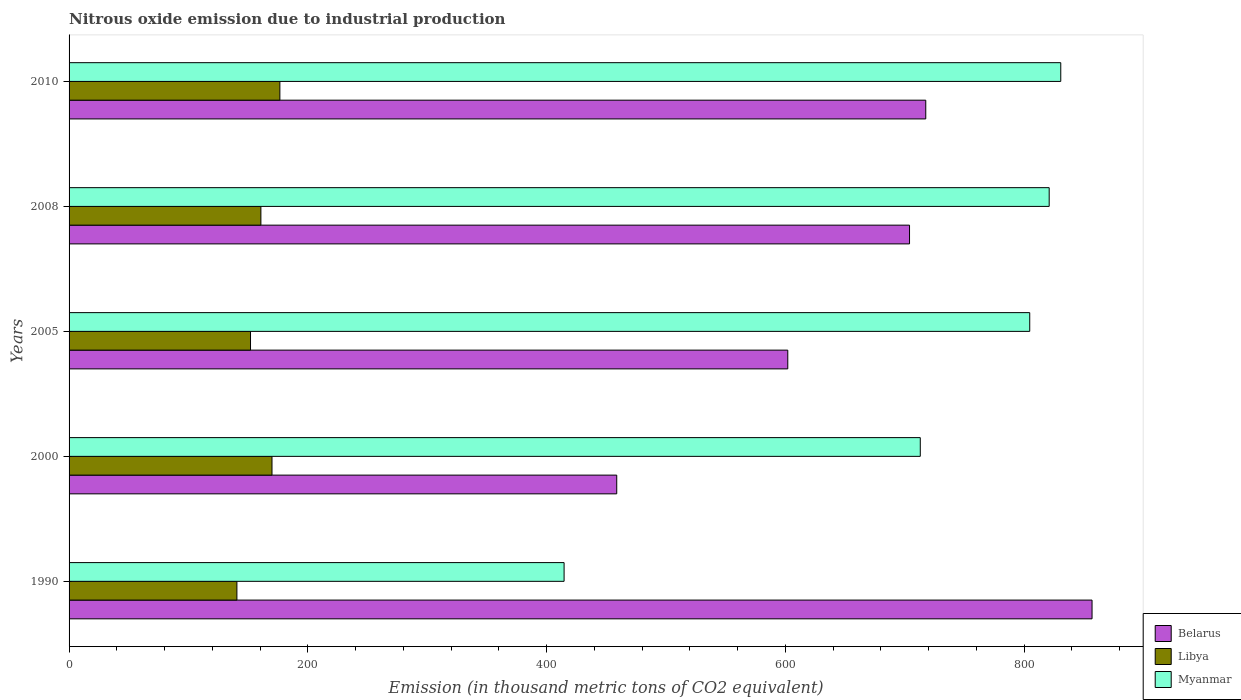How many different coloured bars are there?
Make the answer very short. 3. How many bars are there on the 4th tick from the bottom?
Your answer should be compact. 3. What is the label of the 5th group of bars from the top?
Provide a succinct answer. 1990. In how many cases, is the number of bars for a given year not equal to the number of legend labels?
Give a very brief answer. 0. What is the amount of nitrous oxide emitted in Libya in 2005?
Provide a short and direct response. 152. Across all years, what is the maximum amount of nitrous oxide emitted in Belarus?
Offer a terse response. 857. Across all years, what is the minimum amount of nitrous oxide emitted in Belarus?
Your answer should be very brief. 458.8. What is the total amount of nitrous oxide emitted in Myanmar in the graph?
Offer a very short reply. 3584.5. What is the difference between the amount of nitrous oxide emitted in Belarus in 1990 and that in 2010?
Offer a very short reply. 139.3. What is the difference between the amount of nitrous oxide emitted in Libya in 2010 and the amount of nitrous oxide emitted in Belarus in 2000?
Provide a succinct answer. -282.2. What is the average amount of nitrous oxide emitted in Belarus per year?
Your answer should be very brief. 667.94. In the year 2008, what is the difference between the amount of nitrous oxide emitted in Myanmar and amount of nitrous oxide emitted in Belarus?
Offer a terse response. 117. In how many years, is the amount of nitrous oxide emitted in Libya greater than 640 thousand metric tons?
Make the answer very short. 0. What is the ratio of the amount of nitrous oxide emitted in Libya in 1990 to that in 2008?
Keep it short and to the point. 0.87. What is the difference between the highest and the second highest amount of nitrous oxide emitted in Libya?
Your answer should be compact. 6.6. What is the difference between the highest and the lowest amount of nitrous oxide emitted in Myanmar?
Provide a succinct answer. 416.1. What does the 2nd bar from the top in 1990 represents?
Offer a terse response. Libya. What does the 2nd bar from the bottom in 1990 represents?
Keep it short and to the point. Libya. Are all the bars in the graph horizontal?
Keep it short and to the point. Yes. How many years are there in the graph?
Make the answer very short. 5. Are the values on the major ticks of X-axis written in scientific E-notation?
Give a very brief answer. No. Does the graph contain grids?
Your answer should be very brief. No. What is the title of the graph?
Provide a short and direct response. Nitrous oxide emission due to industrial production. What is the label or title of the X-axis?
Make the answer very short. Emission (in thousand metric tons of CO2 equivalent). What is the label or title of the Y-axis?
Offer a very short reply. Years. What is the Emission (in thousand metric tons of CO2 equivalent) in Belarus in 1990?
Keep it short and to the point. 857. What is the Emission (in thousand metric tons of CO2 equivalent) of Libya in 1990?
Provide a succinct answer. 140.6. What is the Emission (in thousand metric tons of CO2 equivalent) in Myanmar in 1990?
Give a very brief answer. 414.7. What is the Emission (in thousand metric tons of CO2 equivalent) of Belarus in 2000?
Your answer should be compact. 458.8. What is the Emission (in thousand metric tons of CO2 equivalent) of Libya in 2000?
Your answer should be compact. 170. What is the Emission (in thousand metric tons of CO2 equivalent) in Myanmar in 2000?
Give a very brief answer. 713.1. What is the Emission (in thousand metric tons of CO2 equivalent) in Belarus in 2005?
Give a very brief answer. 602.1. What is the Emission (in thousand metric tons of CO2 equivalent) in Libya in 2005?
Your answer should be compact. 152. What is the Emission (in thousand metric tons of CO2 equivalent) in Myanmar in 2005?
Give a very brief answer. 804.8. What is the Emission (in thousand metric tons of CO2 equivalent) in Belarus in 2008?
Keep it short and to the point. 704.1. What is the Emission (in thousand metric tons of CO2 equivalent) of Libya in 2008?
Give a very brief answer. 160.7. What is the Emission (in thousand metric tons of CO2 equivalent) of Myanmar in 2008?
Provide a succinct answer. 821.1. What is the Emission (in thousand metric tons of CO2 equivalent) of Belarus in 2010?
Ensure brevity in your answer.  717.7. What is the Emission (in thousand metric tons of CO2 equivalent) of Libya in 2010?
Give a very brief answer. 176.6. What is the Emission (in thousand metric tons of CO2 equivalent) of Myanmar in 2010?
Provide a short and direct response. 830.8. Across all years, what is the maximum Emission (in thousand metric tons of CO2 equivalent) of Belarus?
Provide a short and direct response. 857. Across all years, what is the maximum Emission (in thousand metric tons of CO2 equivalent) of Libya?
Keep it short and to the point. 176.6. Across all years, what is the maximum Emission (in thousand metric tons of CO2 equivalent) in Myanmar?
Give a very brief answer. 830.8. Across all years, what is the minimum Emission (in thousand metric tons of CO2 equivalent) in Belarus?
Make the answer very short. 458.8. Across all years, what is the minimum Emission (in thousand metric tons of CO2 equivalent) in Libya?
Make the answer very short. 140.6. Across all years, what is the minimum Emission (in thousand metric tons of CO2 equivalent) in Myanmar?
Your answer should be compact. 414.7. What is the total Emission (in thousand metric tons of CO2 equivalent) of Belarus in the graph?
Provide a succinct answer. 3339.7. What is the total Emission (in thousand metric tons of CO2 equivalent) in Libya in the graph?
Give a very brief answer. 799.9. What is the total Emission (in thousand metric tons of CO2 equivalent) in Myanmar in the graph?
Your response must be concise. 3584.5. What is the difference between the Emission (in thousand metric tons of CO2 equivalent) of Belarus in 1990 and that in 2000?
Provide a succinct answer. 398.2. What is the difference between the Emission (in thousand metric tons of CO2 equivalent) of Libya in 1990 and that in 2000?
Your answer should be compact. -29.4. What is the difference between the Emission (in thousand metric tons of CO2 equivalent) of Myanmar in 1990 and that in 2000?
Your response must be concise. -298.4. What is the difference between the Emission (in thousand metric tons of CO2 equivalent) in Belarus in 1990 and that in 2005?
Give a very brief answer. 254.9. What is the difference between the Emission (in thousand metric tons of CO2 equivalent) of Myanmar in 1990 and that in 2005?
Keep it short and to the point. -390.1. What is the difference between the Emission (in thousand metric tons of CO2 equivalent) of Belarus in 1990 and that in 2008?
Your answer should be compact. 152.9. What is the difference between the Emission (in thousand metric tons of CO2 equivalent) in Libya in 1990 and that in 2008?
Keep it short and to the point. -20.1. What is the difference between the Emission (in thousand metric tons of CO2 equivalent) in Myanmar in 1990 and that in 2008?
Offer a very short reply. -406.4. What is the difference between the Emission (in thousand metric tons of CO2 equivalent) of Belarus in 1990 and that in 2010?
Make the answer very short. 139.3. What is the difference between the Emission (in thousand metric tons of CO2 equivalent) in Libya in 1990 and that in 2010?
Offer a terse response. -36. What is the difference between the Emission (in thousand metric tons of CO2 equivalent) in Myanmar in 1990 and that in 2010?
Offer a very short reply. -416.1. What is the difference between the Emission (in thousand metric tons of CO2 equivalent) of Belarus in 2000 and that in 2005?
Ensure brevity in your answer.  -143.3. What is the difference between the Emission (in thousand metric tons of CO2 equivalent) in Myanmar in 2000 and that in 2005?
Give a very brief answer. -91.7. What is the difference between the Emission (in thousand metric tons of CO2 equivalent) of Belarus in 2000 and that in 2008?
Offer a very short reply. -245.3. What is the difference between the Emission (in thousand metric tons of CO2 equivalent) of Libya in 2000 and that in 2008?
Make the answer very short. 9.3. What is the difference between the Emission (in thousand metric tons of CO2 equivalent) in Myanmar in 2000 and that in 2008?
Provide a short and direct response. -108. What is the difference between the Emission (in thousand metric tons of CO2 equivalent) in Belarus in 2000 and that in 2010?
Provide a short and direct response. -258.9. What is the difference between the Emission (in thousand metric tons of CO2 equivalent) of Libya in 2000 and that in 2010?
Provide a succinct answer. -6.6. What is the difference between the Emission (in thousand metric tons of CO2 equivalent) of Myanmar in 2000 and that in 2010?
Offer a terse response. -117.7. What is the difference between the Emission (in thousand metric tons of CO2 equivalent) in Belarus in 2005 and that in 2008?
Keep it short and to the point. -102. What is the difference between the Emission (in thousand metric tons of CO2 equivalent) in Libya in 2005 and that in 2008?
Keep it short and to the point. -8.7. What is the difference between the Emission (in thousand metric tons of CO2 equivalent) of Myanmar in 2005 and that in 2008?
Your answer should be compact. -16.3. What is the difference between the Emission (in thousand metric tons of CO2 equivalent) of Belarus in 2005 and that in 2010?
Your answer should be very brief. -115.6. What is the difference between the Emission (in thousand metric tons of CO2 equivalent) in Libya in 2005 and that in 2010?
Your response must be concise. -24.6. What is the difference between the Emission (in thousand metric tons of CO2 equivalent) in Belarus in 2008 and that in 2010?
Keep it short and to the point. -13.6. What is the difference between the Emission (in thousand metric tons of CO2 equivalent) of Libya in 2008 and that in 2010?
Ensure brevity in your answer.  -15.9. What is the difference between the Emission (in thousand metric tons of CO2 equivalent) of Myanmar in 2008 and that in 2010?
Your answer should be compact. -9.7. What is the difference between the Emission (in thousand metric tons of CO2 equivalent) in Belarus in 1990 and the Emission (in thousand metric tons of CO2 equivalent) in Libya in 2000?
Your answer should be compact. 687. What is the difference between the Emission (in thousand metric tons of CO2 equivalent) of Belarus in 1990 and the Emission (in thousand metric tons of CO2 equivalent) of Myanmar in 2000?
Ensure brevity in your answer.  143.9. What is the difference between the Emission (in thousand metric tons of CO2 equivalent) of Libya in 1990 and the Emission (in thousand metric tons of CO2 equivalent) of Myanmar in 2000?
Provide a succinct answer. -572.5. What is the difference between the Emission (in thousand metric tons of CO2 equivalent) of Belarus in 1990 and the Emission (in thousand metric tons of CO2 equivalent) of Libya in 2005?
Offer a very short reply. 705. What is the difference between the Emission (in thousand metric tons of CO2 equivalent) of Belarus in 1990 and the Emission (in thousand metric tons of CO2 equivalent) of Myanmar in 2005?
Offer a very short reply. 52.2. What is the difference between the Emission (in thousand metric tons of CO2 equivalent) in Libya in 1990 and the Emission (in thousand metric tons of CO2 equivalent) in Myanmar in 2005?
Provide a short and direct response. -664.2. What is the difference between the Emission (in thousand metric tons of CO2 equivalent) in Belarus in 1990 and the Emission (in thousand metric tons of CO2 equivalent) in Libya in 2008?
Offer a terse response. 696.3. What is the difference between the Emission (in thousand metric tons of CO2 equivalent) of Belarus in 1990 and the Emission (in thousand metric tons of CO2 equivalent) of Myanmar in 2008?
Ensure brevity in your answer.  35.9. What is the difference between the Emission (in thousand metric tons of CO2 equivalent) in Libya in 1990 and the Emission (in thousand metric tons of CO2 equivalent) in Myanmar in 2008?
Your answer should be compact. -680.5. What is the difference between the Emission (in thousand metric tons of CO2 equivalent) of Belarus in 1990 and the Emission (in thousand metric tons of CO2 equivalent) of Libya in 2010?
Give a very brief answer. 680.4. What is the difference between the Emission (in thousand metric tons of CO2 equivalent) in Belarus in 1990 and the Emission (in thousand metric tons of CO2 equivalent) in Myanmar in 2010?
Your answer should be very brief. 26.2. What is the difference between the Emission (in thousand metric tons of CO2 equivalent) in Libya in 1990 and the Emission (in thousand metric tons of CO2 equivalent) in Myanmar in 2010?
Your answer should be very brief. -690.2. What is the difference between the Emission (in thousand metric tons of CO2 equivalent) of Belarus in 2000 and the Emission (in thousand metric tons of CO2 equivalent) of Libya in 2005?
Ensure brevity in your answer.  306.8. What is the difference between the Emission (in thousand metric tons of CO2 equivalent) of Belarus in 2000 and the Emission (in thousand metric tons of CO2 equivalent) of Myanmar in 2005?
Keep it short and to the point. -346. What is the difference between the Emission (in thousand metric tons of CO2 equivalent) of Libya in 2000 and the Emission (in thousand metric tons of CO2 equivalent) of Myanmar in 2005?
Offer a very short reply. -634.8. What is the difference between the Emission (in thousand metric tons of CO2 equivalent) in Belarus in 2000 and the Emission (in thousand metric tons of CO2 equivalent) in Libya in 2008?
Offer a very short reply. 298.1. What is the difference between the Emission (in thousand metric tons of CO2 equivalent) in Belarus in 2000 and the Emission (in thousand metric tons of CO2 equivalent) in Myanmar in 2008?
Keep it short and to the point. -362.3. What is the difference between the Emission (in thousand metric tons of CO2 equivalent) in Libya in 2000 and the Emission (in thousand metric tons of CO2 equivalent) in Myanmar in 2008?
Provide a succinct answer. -651.1. What is the difference between the Emission (in thousand metric tons of CO2 equivalent) of Belarus in 2000 and the Emission (in thousand metric tons of CO2 equivalent) of Libya in 2010?
Your answer should be very brief. 282.2. What is the difference between the Emission (in thousand metric tons of CO2 equivalent) in Belarus in 2000 and the Emission (in thousand metric tons of CO2 equivalent) in Myanmar in 2010?
Your answer should be very brief. -372. What is the difference between the Emission (in thousand metric tons of CO2 equivalent) in Libya in 2000 and the Emission (in thousand metric tons of CO2 equivalent) in Myanmar in 2010?
Keep it short and to the point. -660.8. What is the difference between the Emission (in thousand metric tons of CO2 equivalent) in Belarus in 2005 and the Emission (in thousand metric tons of CO2 equivalent) in Libya in 2008?
Your response must be concise. 441.4. What is the difference between the Emission (in thousand metric tons of CO2 equivalent) in Belarus in 2005 and the Emission (in thousand metric tons of CO2 equivalent) in Myanmar in 2008?
Provide a short and direct response. -219. What is the difference between the Emission (in thousand metric tons of CO2 equivalent) of Libya in 2005 and the Emission (in thousand metric tons of CO2 equivalent) of Myanmar in 2008?
Your response must be concise. -669.1. What is the difference between the Emission (in thousand metric tons of CO2 equivalent) of Belarus in 2005 and the Emission (in thousand metric tons of CO2 equivalent) of Libya in 2010?
Make the answer very short. 425.5. What is the difference between the Emission (in thousand metric tons of CO2 equivalent) of Belarus in 2005 and the Emission (in thousand metric tons of CO2 equivalent) of Myanmar in 2010?
Your answer should be very brief. -228.7. What is the difference between the Emission (in thousand metric tons of CO2 equivalent) in Libya in 2005 and the Emission (in thousand metric tons of CO2 equivalent) in Myanmar in 2010?
Ensure brevity in your answer.  -678.8. What is the difference between the Emission (in thousand metric tons of CO2 equivalent) in Belarus in 2008 and the Emission (in thousand metric tons of CO2 equivalent) in Libya in 2010?
Give a very brief answer. 527.5. What is the difference between the Emission (in thousand metric tons of CO2 equivalent) in Belarus in 2008 and the Emission (in thousand metric tons of CO2 equivalent) in Myanmar in 2010?
Make the answer very short. -126.7. What is the difference between the Emission (in thousand metric tons of CO2 equivalent) of Libya in 2008 and the Emission (in thousand metric tons of CO2 equivalent) of Myanmar in 2010?
Offer a terse response. -670.1. What is the average Emission (in thousand metric tons of CO2 equivalent) of Belarus per year?
Provide a short and direct response. 667.94. What is the average Emission (in thousand metric tons of CO2 equivalent) in Libya per year?
Keep it short and to the point. 159.98. What is the average Emission (in thousand metric tons of CO2 equivalent) in Myanmar per year?
Give a very brief answer. 716.9. In the year 1990, what is the difference between the Emission (in thousand metric tons of CO2 equivalent) in Belarus and Emission (in thousand metric tons of CO2 equivalent) in Libya?
Offer a terse response. 716.4. In the year 1990, what is the difference between the Emission (in thousand metric tons of CO2 equivalent) of Belarus and Emission (in thousand metric tons of CO2 equivalent) of Myanmar?
Ensure brevity in your answer.  442.3. In the year 1990, what is the difference between the Emission (in thousand metric tons of CO2 equivalent) in Libya and Emission (in thousand metric tons of CO2 equivalent) in Myanmar?
Your answer should be very brief. -274.1. In the year 2000, what is the difference between the Emission (in thousand metric tons of CO2 equivalent) of Belarus and Emission (in thousand metric tons of CO2 equivalent) of Libya?
Offer a terse response. 288.8. In the year 2000, what is the difference between the Emission (in thousand metric tons of CO2 equivalent) of Belarus and Emission (in thousand metric tons of CO2 equivalent) of Myanmar?
Offer a very short reply. -254.3. In the year 2000, what is the difference between the Emission (in thousand metric tons of CO2 equivalent) of Libya and Emission (in thousand metric tons of CO2 equivalent) of Myanmar?
Your answer should be compact. -543.1. In the year 2005, what is the difference between the Emission (in thousand metric tons of CO2 equivalent) in Belarus and Emission (in thousand metric tons of CO2 equivalent) in Libya?
Ensure brevity in your answer.  450.1. In the year 2005, what is the difference between the Emission (in thousand metric tons of CO2 equivalent) of Belarus and Emission (in thousand metric tons of CO2 equivalent) of Myanmar?
Keep it short and to the point. -202.7. In the year 2005, what is the difference between the Emission (in thousand metric tons of CO2 equivalent) in Libya and Emission (in thousand metric tons of CO2 equivalent) in Myanmar?
Offer a terse response. -652.8. In the year 2008, what is the difference between the Emission (in thousand metric tons of CO2 equivalent) of Belarus and Emission (in thousand metric tons of CO2 equivalent) of Libya?
Ensure brevity in your answer.  543.4. In the year 2008, what is the difference between the Emission (in thousand metric tons of CO2 equivalent) of Belarus and Emission (in thousand metric tons of CO2 equivalent) of Myanmar?
Provide a succinct answer. -117. In the year 2008, what is the difference between the Emission (in thousand metric tons of CO2 equivalent) of Libya and Emission (in thousand metric tons of CO2 equivalent) of Myanmar?
Offer a terse response. -660.4. In the year 2010, what is the difference between the Emission (in thousand metric tons of CO2 equivalent) in Belarus and Emission (in thousand metric tons of CO2 equivalent) in Libya?
Give a very brief answer. 541.1. In the year 2010, what is the difference between the Emission (in thousand metric tons of CO2 equivalent) in Belarus and Emission (in thousand metric tons of CO2 equivalent) in Myanmar?
Provide a succinct answer. -113.1. In the year 2010, what is the difference between the Emission (in thousand metric tons of CO2 equivalent) in Libya and Emission (in thousand metric tons of CO2 equivalent) in Myanmar?
Your answer should be very brief. -654.2. What is the ratio of the Emission (in thousand metric tons of CO2 equivalent) of Belarus in 1990 to that in 2000?
Give a very brief answer. 1.87. What is the ratio of the Emission (in thousand metric tons of CO2 equivalent) in Libya in 1990 to that in 2000?
Your response must be concise. 0.83. What is the ratio of the Emission (in thousand metric tons of CO2 equivalent) of Myanmar in 1990 to that in 2000?
Give a very brief answer. 0.58. What is the ratio of the Emission (in thousand metric tons of CO2 equivalent) in Belarus in 1990 to that in 2005?
Ensure brevity in your answer.  1.42. What is the ratio of the Emission (in thousand metric tons of CO2 equivalent) in Libya in 1990 to that in 2005?
Keep it short and to the point. 0.93. What is the ratio of the Emission (in thousand metric tons of CO2 equivalent) in Myanmar in 1990 to that in 2005?
Your answer should be compact. 0.52. What is the ratio of the Emission (in thousand metric tons of CO2 equivalent) in Belarus in 1990 to that in 2008?
Ensure brevity in your answer.  1.22. What is the ratio of the Emission (in thousand metric tons of CO2 equivalent) of Libya in 1990 to that in 2008?
Your response must be concise. 0.87. What is the ratio of the Emission (in thousand metric tons of CO2 equivalent) in Myanmar in 1990 to that in 2008?
Your answer should be very brief. 0.51. What is the ratio of the Emission (in thousand metric tons of CO2 equivalent) in Belarus in 1990 to that in 2010?
Make the answer very short. 1.19. What is the ratio of the Emission (in thousand metric tons of CO2 equivalent) of Libya in 1990 to that in 2010?
Your answer should be compact. 0.8. What is the ratio of the Emission (in thousand metric tons of CO2 equivalent) of Myanmar in 1990 to that in 2010?
Your answer should be compact. 0.5. What is the ratio of the Emission (in thousand metric tons of CO2 equivalent) of Belarus in 2000 to that in 2005?
Give a very brief answer. 0.76. What is the ratio of the Emission (in thousand metric tons of CO2 equivalent) of Libya in 2000 to that in 2005?
Provide a succinct answer. 1.12. What is the ratio of the Emission (in thousand metric tons of CO2 equivalent) of Myanmar in 2000 to that in 2005?
Offer a very short reply. 0.89. What is the ratio of the Emission (in thousand metric tons of CO2 equivalent) of Belarus in 2000 to that in 2008?
Your answer should be compact. 0.65. What is the ratio of the Emission (in thousand metric tons of CO2 equivalent) in Libya in 2000 to that in 2008?
Provide a succinct answer. 1.06. What is the ratio of the Emission (in thousand metric tons of CO2 equivalent) of Myanmar in 2000 to that in 2008?
Keep it short and to the point. 0.87. What is the ratio of the Emission (in thousand metric tons of CO2 equivalent) of Belarus in 2000 to that in 2010?
Keep it short and to the point. 0.64. What is the ratio of the Emission (in thousand metric tons of CO2 equivalent) in Libya in 2000 to that in 2010?
Provide a succinct answer. 0.96. What is the ratio of the Emission (in thousand metric tons of CO2 equivalent) in Myanmar in 2000 to that in 2010?
Your response must be concise. 0.86. What is the ratio of the Emission (in thousand metric tons of CO2 equivalent) of Belarus in 2005 to that in 2008?
Ensure brevity in your answer.  0.86. What is the ratio of the Emission (in thousand metric tons of CO2 equivalent) of Libya in 2005 to that in 2008?
Offer a very short reply. 0.95. What is the ratio of the Emission (in thousand metric tons of CO2 equivalent) in Myanmar in 2005 to that in 2008?
Give a very brief answer. 0.98. What is the ratio of the Emission (in thousand metric tons of CO2 equivalent) of Belarus in 2005 to that in 2010?
Give a very brief answer. 0.84. What is the ratio of the Emission (in thousand metric tons of CO2 equivalent) in Libya in 2005 to that in 2010?
Your answer should be compact. 0.86. What is the ratio of the Emission (in thousand metric tons of CO2 equivalent) of Myanmar in 2005 to that in 2010?
Provide a short and direct response. 0.97. What is the ratio of the Emission (in thousand metric tons of CO2 equivalent) in Belarus in 2008 to that in 2010?
Provide a short and direct response. 0.98. What is the ratio of the Emission (in thousand metric tons of CO2 equivalent) in Libya in 2008 to that in 2010?
Your response must be concise. 0.91. What is the ratio of the Emission (in thousand metric tons of CO2 equivalent) of Myanmar in 2008 to that in 2010?
Give a very brief answer. 0.99. What is the difference between the highest and the second highest Emission (in thousand metric tons of CO2 equivalent) in Belarus?
Give a very brief answer. 139.3. What is the difference between the highest and the second highest Emission (in thousand metric tons of CO2 equivalent) of Libya?
Make the answer very short. 6.6. What is the difference between the highest and the lowest Emission (in thousand metric tons of CO2 equivalent) of Belarus?
Make the answer very short. 398.2. What is the difference between the highest and the lowest Emission (in thousand metric tons of CO2 equivalent) in Myanmar?
Offer a terse response. 416.1. 